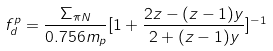Convert formula to latex. <formula><loc_0><loc_0><loc_500><loc_500>f ^ { p } _ { d } = \frac { \Sigma _ { \pi N } } { 0 . 7 5 6 m _ { p } } [ 1 + \frac { 2 z - ( z - 1 ) y } { 2 + ( z - 1 ) y } ] ^ { - 1 }</formula> 